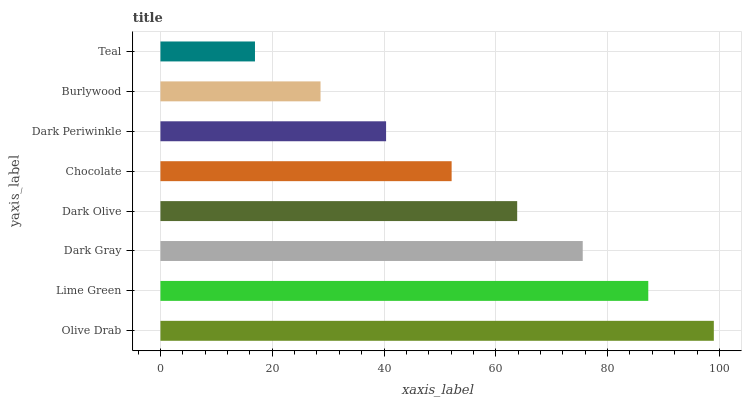Is Teal the minimum?
Answer yes or no. Yes. Is Olive Drab the maximum?
Answer yes or no. Yes. Is Lime Green the minimum?
Answer yes or no. No. Is Lime Green the maximum?
Answer yes or no. No. Is Olive Drab greater than Lime Green?
Answer yes or no. Yes. Is Lime Green less than Olive Drab?
Answer yes or no. Yes. Is Lime Green greater than Olive Drab?
Answer yes or no. No. Is Olive Drab less than Lime Green?
Answer yes or no. No. Is Dark Olive the high median?
Answer yes or no. Yes. Is Chocolate the low median?
Answer yes or no. Yes. Is Olive Drab the high median?
Answer yes or no. No. Is Teal the low median?
Answer yes or no. No. 